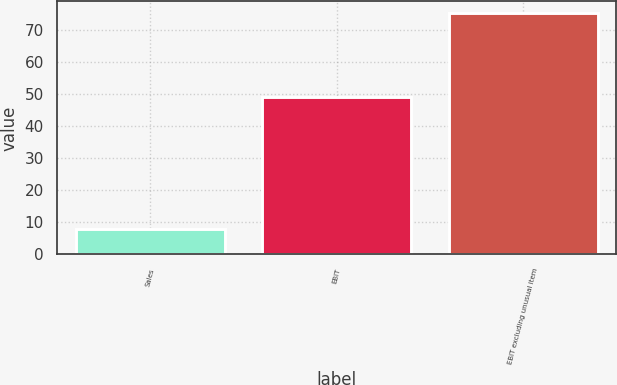<chart> <loc_0><loc_0><loc_500><loc_500><bar_chart><fcel>Sales<fcel>EBIT<fcel>EBIT excluding unusual item<nl><fcel>8<fcel>49<fcel>75<nl></chart> 